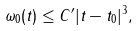<formula> <loc_0><loc_0><loc_500><loc_500>\omega _ { 0 } ( t ) \leq C ^ { \prime } | t - t _ { 0 } | ^ { 3 } ,</formula> 